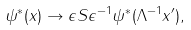<formula> <loc_0><loc_0><loc_500><loc_500>\psi ^ { * } ( x ) \rightarrow \epsilon S \epsilon ^ { - 1 } \psi ^ { * } ( \Lambda ^ { - 1 } x ^ { \prime } ) ,</formula> 